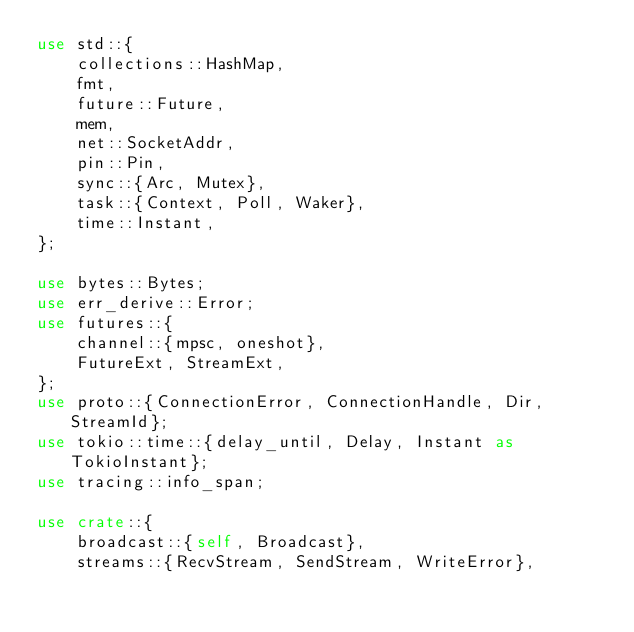<code> <loc_0><loc_0><loc_500><loc_500><_Rust_>use std::{
    collections::HashMap,
    fmt,
    future::Future,
    mem,
    net::SocketAddr,
    pin::Pin,
    sync::{Arc, Mutex},
    task::{Context, Poll, Waker},
    time::Instant,
};

use bytes::Bytes;
use err_derive::Error;
use futures::{
    channel::{mpsc, oneshot},
    FutureExt, StreamExt,
};
use proto::{ConnectionError, ConnectionHandle, Dir, StreamId};
use tokio::time::{delay_until, Delay, Instant as TokioInstant};
use tracing::info_span;

use crate::{
    broadcast::{self, Broadcast},
    streams::{RecvStream, SendStream, WriteError},</code> 